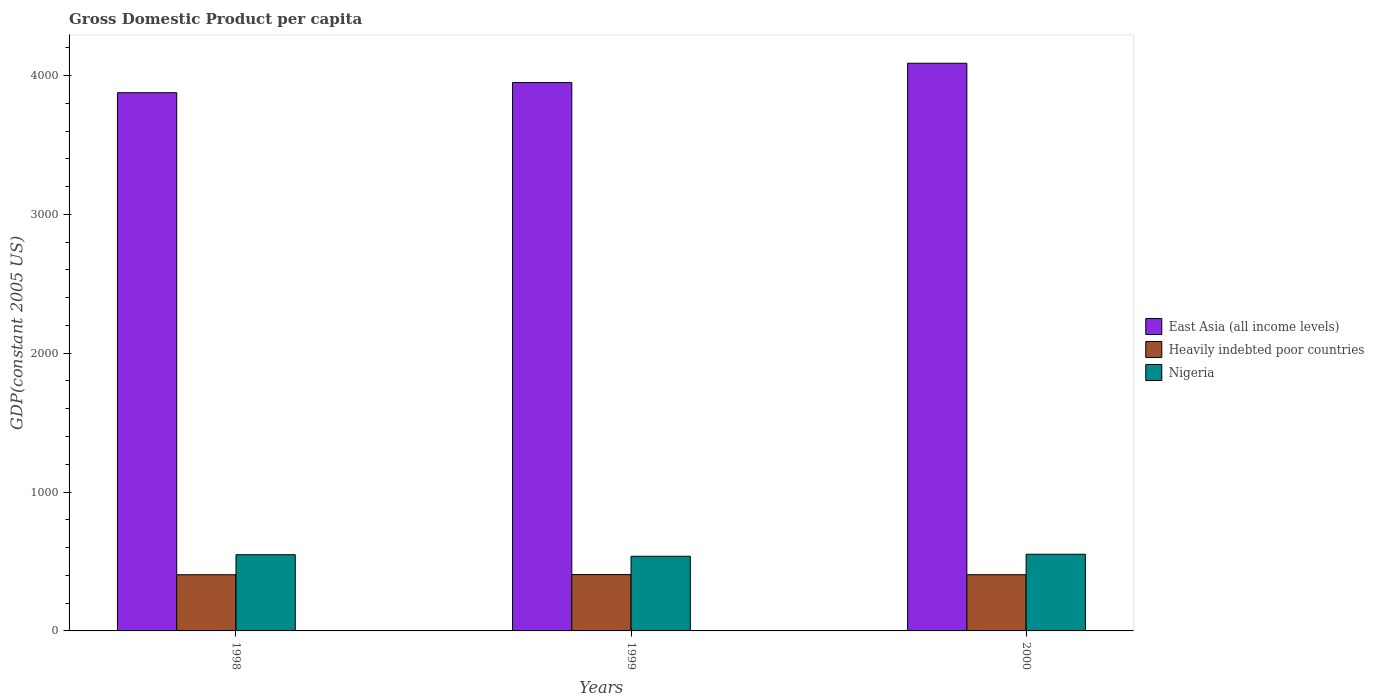How many different coloured bars are there?
Your answer should be very brief. 3. How many groups of bars are there?
Provide a short and direct response. 3. Are the number of bars per tick equal to the number of legend labels?
Keep it short and to the point. Yes. Are the number of bars on each tick of the X-axis equal?
Provide a short and direct response. Yes. How many bars are there on the 3rd tick from the right?
Give a very brief answer. 3. In how many cases, is the number of bars for a given year not equal to the number of legend labels?
Your response must be concise. 0. What is the GDP per capita in East Asia (all income levels) in 2000?
Make the answer very short. 4088.24. Across all years, what is the maximum GDP per capita in East Asia (all income levels)?
Ensure brevity in your answer.  4088.24. Across all years, what is the minimum GDP per capita in East Asia (all income levels)?
Your answer should be very brief. 3875.97. What is the total GDP per capita in Nigeria in the graph?
Your answer should be compact. 1638.53. What is the difference between the GDP per capita in Nigeria in 1999 and that in 2000?
Give a very brief answer. -14.54. What is the difference between the GDP per capita in Heavily indebted poor countries in 2000 and the GDP per capita in Nigeria in 1998?
Ensure brevity in your answer.  -143.85. What is the average GDP per capita in Heavily indebted poor countries per year?
Offer a terse response. 405.03. In the year 2000, what is the difference between the GDP per capita in Nigeria and GDP per capita in Heavily indebted poor countries?
Your answer should be compact. 147.35. In how many years, is the GDP per capita in Heavily indebted poor countries greater than 2200 US$?
Ensure brevity in your answer.  0. What is the ratio of the GDP per capita in Nigeria in 1999 to that in 2000?
Give a very brief answer. 0.97. Is the GDP per capita in East Asia (all income levels) in 1998 less than that in 1999?
Make the answer very short. Yes. Is the difference between the GDP per capita in Nigeria in 1999 and 2000 greater than the difference between the GDP per capita in Heavily indebted poor countries in 1999 and 2000?
Your answer should be very brief. No. What is the difference between the highest and the second highest GDP per capita in Nigeria?
Provide a short and direct response. 3.49. What is the difference between the highest and the lowest GDP per capita in Heavily indebted poor countries?
Make the answer very short. 1.11. What does the 2nd bar from the left in 1998 represents?
Ensure brevity in your answer.  Heavily indebted poor countries. What does the 1st bar from the right in 1999 represents?
Make the answer very short. Nigeria. Is it the case that in every year, the sum of the GDP per capita in East Asia (all income levels) and GDP per capita in Heavily indebted poor countries is greater than the GDP per capita in Nigeria?
Provide a succinct answer. Yes. How many bars are there?
Provide a short and direct response. 9. Are all the bars in the graph horizontal?
Ensure brevity in your answer.  No. How many years are there in the graph?
Provide a short and direct response. 3. What is the difference between two consecutive major ticks on the Y-axis?
Make the answer very short. 1000. Are the values on the major ticks of Y-axis written in scientific E-notation?
Your response must be concise. No. Does the graph contain any zero values?
Offer a terse response. No. Does the graph contain grids?
Make the answer very short. No. How many legend labels are there?
Provide a succinct answer. 3. How are the legend labels stacked?
Your answer should be compact. Vertical. What is the title of the graph?
Your response must be concise. Gross Domestic Product per capita. What is the label or title of the Y-axis?
Give a very brief answer. GDP(constant 2005 US). What is the GDP(constant 2005 US) of East Asia (all income levels) in 1998?
Your response must be concise. 3875.97. What is the GDP(constant 2005 US) of Heavily indebted poor countries in 1998?
Your answer should be very brief. 404.57. What is the GDP(constant 2005 US) of Nigeria in 1998?
Provide a succinct answer. 548.69. What is the GDP(constant 2005 US) in East Asia (all income levels) in 1999?
Offer a terse response. 3949.28. What is the GDP(constant 2005 US) in Heavily indebted poor countries in 1999?
Your answer should be very brief. 405.68. What is the GDP(constant 2005 US) of Nigeria in 1999?
Offer a terse response. 537.65. What is the GDP(constant 2005 US) of East Asia (all income levels) in 2000?
Provide a succinct answer. 4088.24. What is the GDP(constant 2005 US) of Heavily indebted poor countries in 2000?
Your response must be concise. 404.84. What is the GDP(constant 2005 US) of Nigeria in 2000?
Ensure brevity in your answer.  552.19. Across all years, what is the maximum GDP(constant 2005 US) of East Asia (all income levels)?
Give a very brief answer. 4088.24. Across all years, what is the maximum GDP(constant 2005 US) in Heavily indebted poor countries?
Your answer should be compact. 405.68. Across all years, what is the maximum GDP(constant 2005 US) of Nigeria?
Provide a succinct answer. 552.19. Across all years, what is the minimum GDP(constant 2005 US) of East Asia (all income levels)?
Your answer should be compact. 3875.97. Across all years, what is the minimum GDP(constant 2005 US) in Heavily indebted poor countries?
Make the answer very short. 404.57. Across all years, what is the minimum GDP(constant 2005 US) in Nigeria?
Keep it short and to the point. 537.65. What is the total GDP(constant 2005 US) in East Asia (all income levels) in the graph?
Provide a short and direct response. 1.19e+04. What is the total GDP(constant 2005 US) in Heavily indebted poor countries in the graph?
Your answer should be compact. 1215.09. What is the total GDP(constant 2005 US) in Nigeria in the graph?
Make the answer very short. 1638.53. What is the difference between the GDP(constant 2005 US) in East Asia (all income levels) in 1998 and that in 1999?
Keep it short and to the point. -73.3. What is the difference between the GDP(constant 2005 US) in Heavily indebted poor countries in 1998 and that in 1999?
Offer a very short reply. -1.11. What is the difference between the GDP(constant 2005 US) in Nigeria in 1998 and that in 1999?
Give a very brief answer. 11.04. What is the difference between the GDP(constant 2005 US) of East Asia (all income levels) in 1998 and that in 2000?
Your response must be concise. -212.27. What is the difference between the GDP(constant 2005 US) in Heavily indebted poor countries in 1998 and that in 2000?
Ensure brevity in your answer.  -0.27. What is the difference between the GDP(constant 2005 US) of Nigeria in 1998 and that in 2000?
Keep it short and to the point. -3.49. What is the difference between the GDP(constant 2005 US) in East Asia (all income levels) in 1999 and that in 2000?
Keep it short and to the point. -138.97. What is the difference between the GDP(constant 2005 US) in Heavily indebted poor countries in 1999 and that in 2000?
Offer a terse response. 0.84. What is the difference between the GDP(constant 2005 US) of Nigeria in 1999 and that in 2000?
Offer a very short reply. -14.54. What is the difference between the GDP(constant 2005 US) of East Asia (all income levels) in 1998 and the GDP(constant 2005 US) of Heavily indebted poor countries in 1999?
Provide a succinct answer. 3470.29. What is the difference between the GDP(constant 2005 US) in East Asia (all income levels) in 1998 and the GDP(constant 2005 US) in Nigeria in 1999?
Make the answer very short. 3338.32. What is the difference between the GDP(constant 2005 US) in Heavily indebted poor countries in 1998 and the GDP(constant 2005 US) in Nigeria in 1999?
Provide a succinct answer. -133.08. What is the difference between the GDP(constant 2005 US) of East Asia (all income levels) in 1998 and the GDP(constant 2005 US) of Heavily indebted poor countries in 2000?
Your answer should be very brief. 3471.13. What is the difference between the GDP(constant 2005 US) in East Asia (all income levels) in 1998 and the GDP(constant 2005 US) in Nigeria in 2000?
Keep it short and to the point. 3323.78. What is the difference between the GDP(constant 2005 US) of Heavily indebted poor countries in 1998 and the GDP(constant 2005 US) of Nigeria in 2000?
Give a very brief answer. -147.61. What is the difference between the GDP(constant 2005 US) in East Asia (all income levels) in 1999 and the GDP(constant 2005 US) in Heavily indebted poor countries in 2000?
Offer a very short reply. 3544.43. What is the difference between the GDP(constant 2005 US) of East Asia (all income levels) in 1999 and the GDP(constant 2005 US) of Nigeria in 2000?
Make the answer very short. 3397.09. What is the difference between the GDP(constant 2005 US) in Heavily indebted poor countries in 1999 and the GDP(constant 2005 US) in Nigeria in 2000?
Your response must be concise. -146.51. What is the average GDP(constant 2005 US) of East Asia (all income levels) per year?
Make the answer very short. 3971.16. What is the average GDP(constant 2005 US) of Heavily indebted poor countries per year?
Ensure brevity in your answer.  405.03. What is the average GDP(constant 2005 US) of Nigeria per year?
Make the answer very short. 546.18. In the year 1998, what is the difference between the GDP(constant 2005 US) in East Asia (all income levels) and GDP(constant 2005 US) in Heavily indebted poor countries?
Provide a succinct answer. 3471.4. In the year 1998, what is the difference between the GDP(constant 2005 US) of East Asia (all income levels) and GDP(constant 2005 US) of Nigeria?
Make the answer very short. 3327.28. In the year 1998, what is the difference between the GDP(constant 2005 US) in Heavily indebted poor countries and GDP(constant 2005 US) in Nigeria?
Ensure brevity in your answer.  -144.12. In the year 1999, what is the difference between the GDP(constant 2005 US) in East Asia (all income levels) and GDP(constant 2005 US) in Heavily indebted poor countries?
Provide a succinct answer. 3543.59. In the year 1999, what is the difference between the GDP(constant 2005 US) in East Asia (all income levels) and GDP(constant 2005 US) in Nigeria?
Offer a terse response. 3411.62. In the year 1999, what is the difference between the GDP(constant 2005 US) in Heavily indebted poor countries and GDP(constant 2005 US) in Nigeria?
Provide a succinct answer. -131.97. In the year 2000, what is the difference between the GDP(constant 2005 US) of East Asia (all income levels) and GDP(constant 2005 US) of Heavily indebted poor countries?
Your answer should be very brief. 3683.4. In the year 2000, what is the difference between the GDP(constant 2005 US) of East Asia (all income levels) and GDP(constant 2005 US) of Nigeria?
Offer a very short reply. 3536.05. In the year 2000, what is the difference between the GDP(constant 2005 US) of Heavily indebted poor countries and GDP(constant 2005 US) of Nigeria?
Your response must be concise. -147.35. What is the ratio of the GDP(constant 2005 US) in East Asia (all income levels) in 1998 to that in 1999?
Give a very brief answer. 0.98. What is the ratio of the GDP(constant 2005 US) of Nigeria in 1998 to that in 1999?
Your answer should be very brief. 1.02. What is the ratio of the GDP(constant 2005 US) in East Asia (all income levels) in 1998 to that in 2000?
Ensure brevity in your answer.  0.95. What is the ratio of the GDP(constant 2005 US) in Heavily indebted poor countries in 1998 to that in 2000?
Offer a very short reply. 1. What is the ratio of the GDP(constant 2005 US) of Nigeria in 1998 to that in 2000?
Offer a terse response. 0.99. What is the ratio of the GDP(constant 2005 US) in Heavily indebted poor countries in 1999 to that in 2000?
Provide a short and direct response. 1. What is the ratio of the GDP(constant 2005 US) of Nigeria in 1999 to that in 2000?
Your answer should be very brief. 0.97. What is the difference between the highest and the second highest GDP(constant 2005 US) in East Asia (all income levels)?
Offer a terse response. 138.97. What is the difference between the highest and the second highest GDP(constant 2005 US) of Heavily indebted poor countries?
Offer a terse response. 0.84. What is the difference between the highest and the second highest GDP(constant 2005 US) in Nigeria?
Your response must be concise. 3.49. What is the difference between the highest and the lowest GDP(constant 2005 US) of East Asia (all income levels)?
Your answer should be very brief. 212.27. What is the difference between the highest and the lowest GDP(constant 2005 US) of Heavily indebted poor countries?
Provide a short and direct response. 1.11. What is the difference between the highest and the lowest GDP(constant 2005 US) in Nigeria?
Your response must be concise. 14.54. 